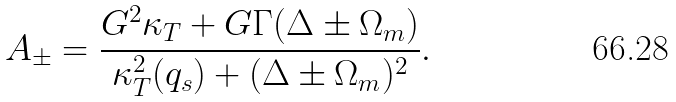Convert formula to latex. <formula><loc_0><loc_0><loc_500><loc_500>A _ { \pm } = \frac { G ^ { 2 } \kappa _ { T } + G \Gamma ( \Delta \pm \Omega _ { m } ) } { \kappa _ { T } ^ { 2 } ( q _ { s } ) + ( \Delta \pm \Omega _ { m } ) ^ { 2 } } .</formula> 